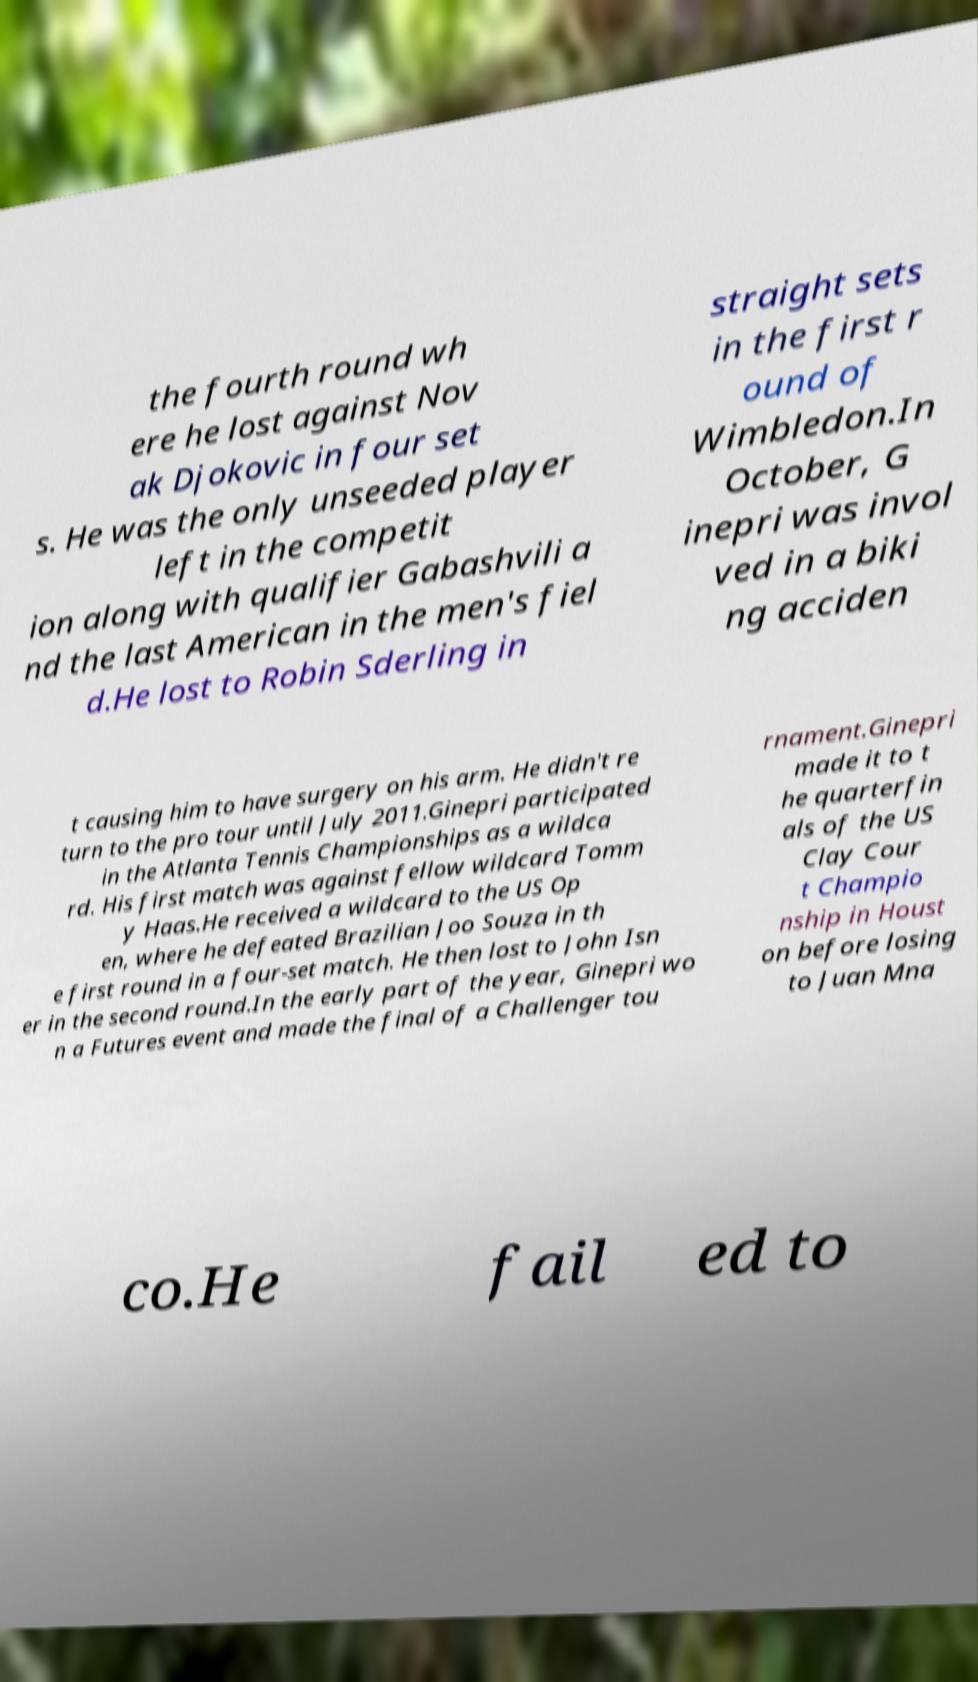What messages or text are displayed in this image? I need them in a readable, typed format. the fourth round wh ere he lost against Nov ak Djokovic in four set s. He was the only unseeded player left in the competit ion along with qualifier Gabashvili a nd the last American in the men's fiel d.He lost to Robin Sderling in straight sets in the first r ound of Wimbledon.In October, G inepri was invol ved in a biki ng acciden t causing him to have surgery on his arm. He didn't re turn to the pro tour until July 2011.Ginepri participated in the Atlanta Tennis Championships as a wildca rd. His first match was against fellow wildcard Tomm y Haas.He received a wildcard to the US Op en, where he defeated Brazilian Joo Souza in th e first round in a four-set match. He then lost to John Isn er in the second round.In the early part of the year, Ginepri wo n a Futures event and made the final of a Challenger tou rnament.Ginepri made it to t he quarterfin als of the US Clay Cour t Champio nship in Houst on before losing to Juan Mna co.He fail ed to 